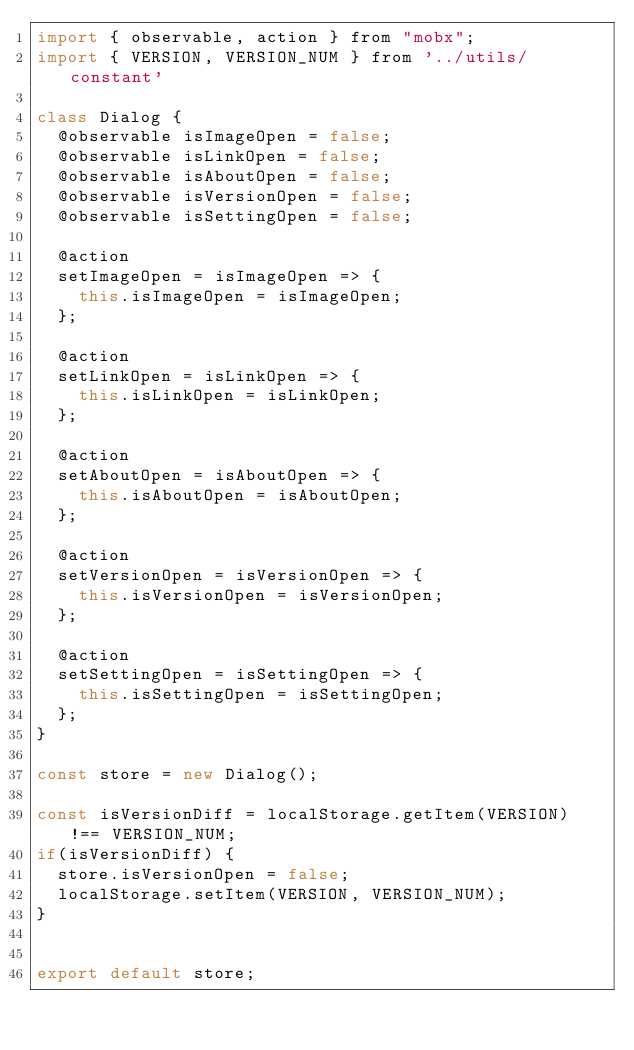Convert code to text. <code><loc_0><loc_0><loc_500><loc_500><_JavaScript_>import { observable, action } from "mobx";
import { VERSION, VERSION_NUM } from '../utils/constant'

class Dialog {
  @observable isImageOpen = false;
  @observable isLinkOpen = false;
  @observable isAboutOpen = false;
  @observable isVersionOpen = false;
  @observable isSettingOpen = false;

  @action
  setImageOpen = isImageOpen => {
    this.isImageOpen = isImageOpen;
  };

  @action
  setLinkOpen = isLinkOpen => {
    this.isLinkOpen = isLinkOpen;
  };

  @action
  setAboutOpen = isAboutOpen => {
    this.isAboutOpen = isAboutOpen;
  };

  @action
  setVersionOpen = isVersionOpen => {
    this.isVersionOpen = isVersionOpen;
  };

  @action
  setSettingOpen = isSettingOpen => {
    this.isSettingOpen = isSettingOpen;
  };
}

const store = new Dialog();

const isVersionDiff = localStorage.getItem(VERSION) !== VERSION_NUM;
if(isVersionDiff) {
  store.isVersionOpen = false;
  localStorage.setItem(VERSION, VERSION_NUM);
}


export default store;
</code> 